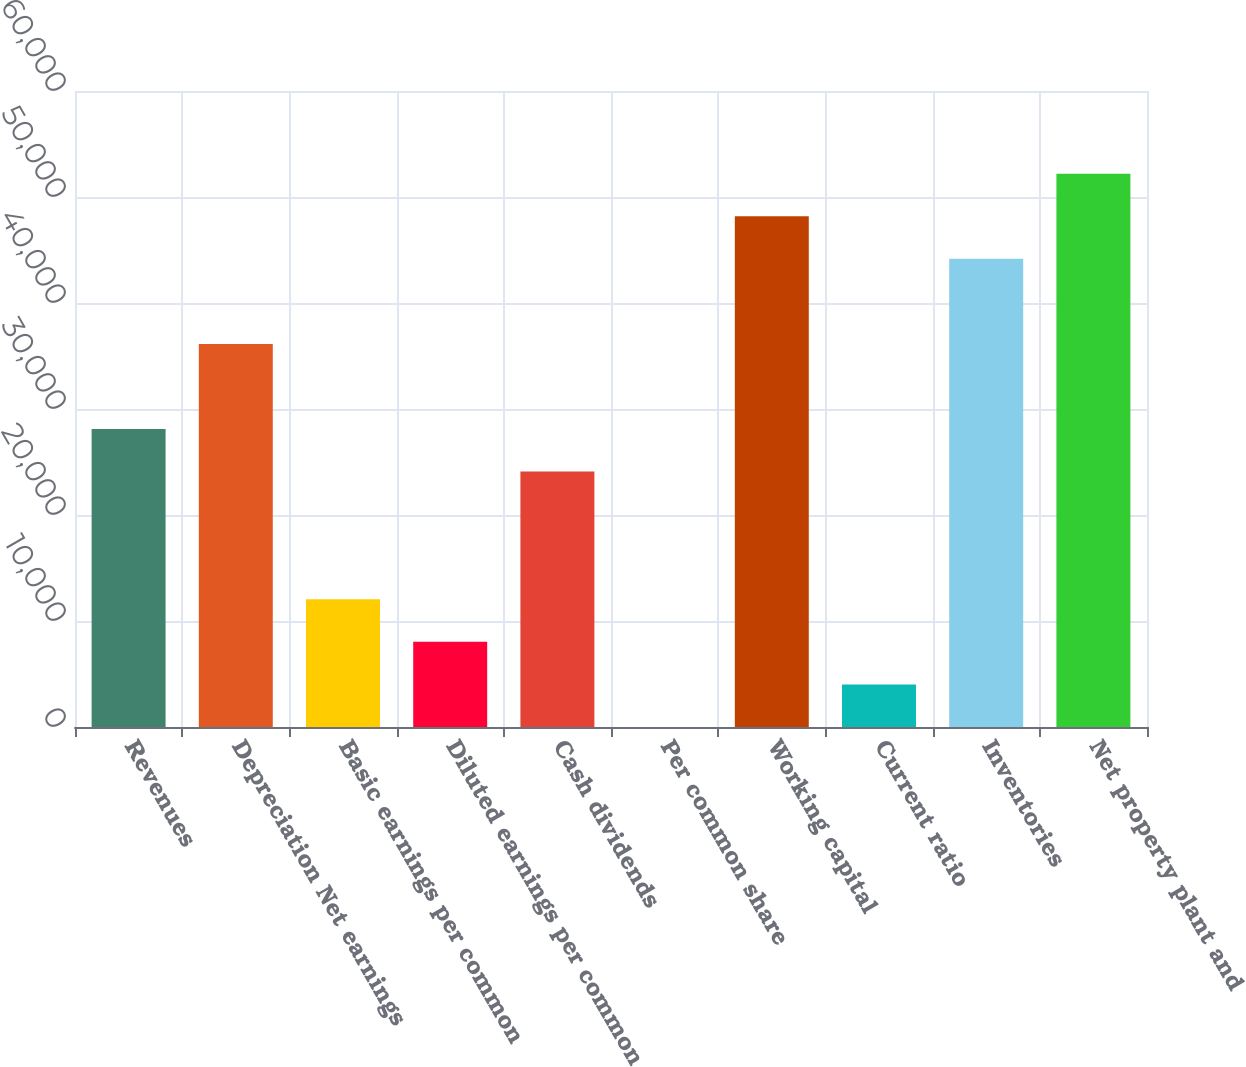Convert chart. <chart><loc_0><loc_0><loc_500><loc_500><bar_chart><fcel>Revenues<fcel>Depreciation Net earnings<fcel>Basic earnings per common<fcel>Diluted earnings per common<fcel>Cash dividends<fcel>Per common share<fcel>Working capital<fcel>Current ratio<fcel>Inventories<fcel>Net property plant and<nl><fcel>28110.2<fcel>36141.4<fcel>12047.9<fcel>8032.3<fcel>24094.7<fcel>1.12<fcel>48188.2<fcel>4016.71<fcel>44172.6<fcel>52203.8<nl></chart> 